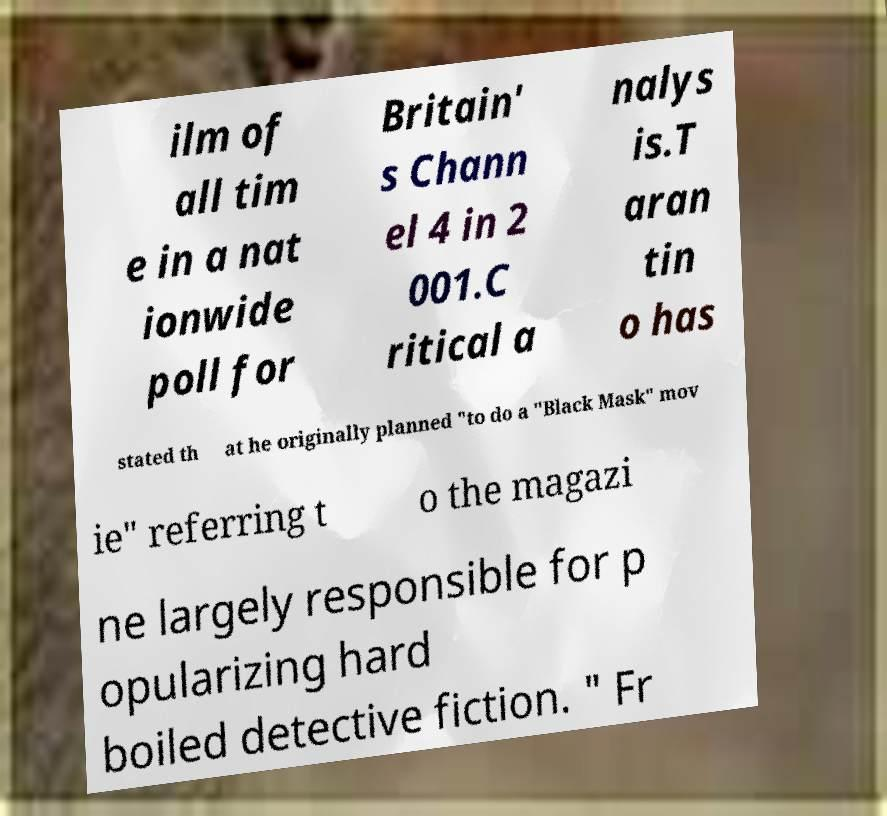There's text embedded in this image that I need extracted. Can you transcribe it verbatim? ilm of all tim e in a nat ionwide poll for Britain' s Chann el 4 in 2 001.C ritical a nalys is.T aran tin o has stated th at he originally planned "to do a "Black Mask" mov ie" referring t o the magazi ne largely responsible for p opularizing hard boiled detective fiction. " Fr 